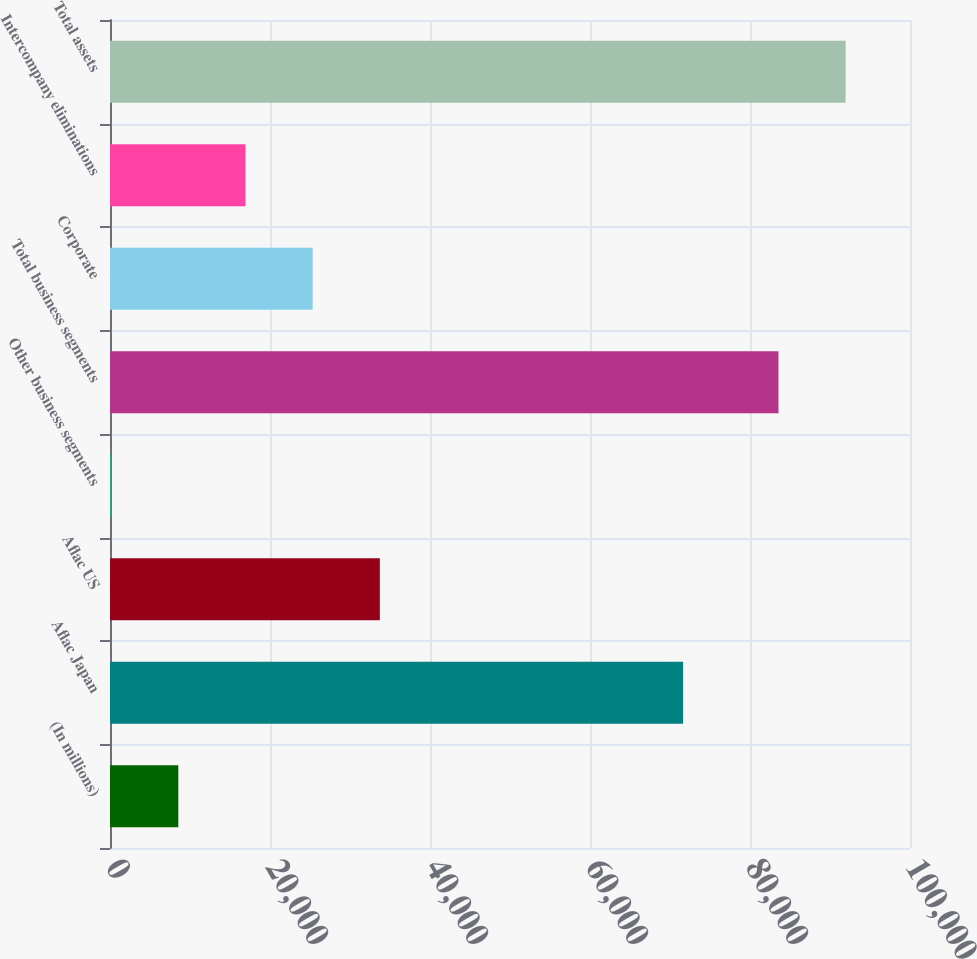<chart> <loc_0><loc_0><loc_500><loc_500><bar_chart><fcel>(In millions)<fcel>Aflac Japan<fcel>Aflac US<fcel>Other business segments<fcel>Total business segments<fcel>Corporate<fcel>Intercompany eliminations<fcel>Total assets<nl><fcel>8538.4<fcel>71639<fcel>33727.6<fcel>142<fcel>83560<fcel>25331.2<fcel>16934.8<fcel>91956.4<nl></chart> 